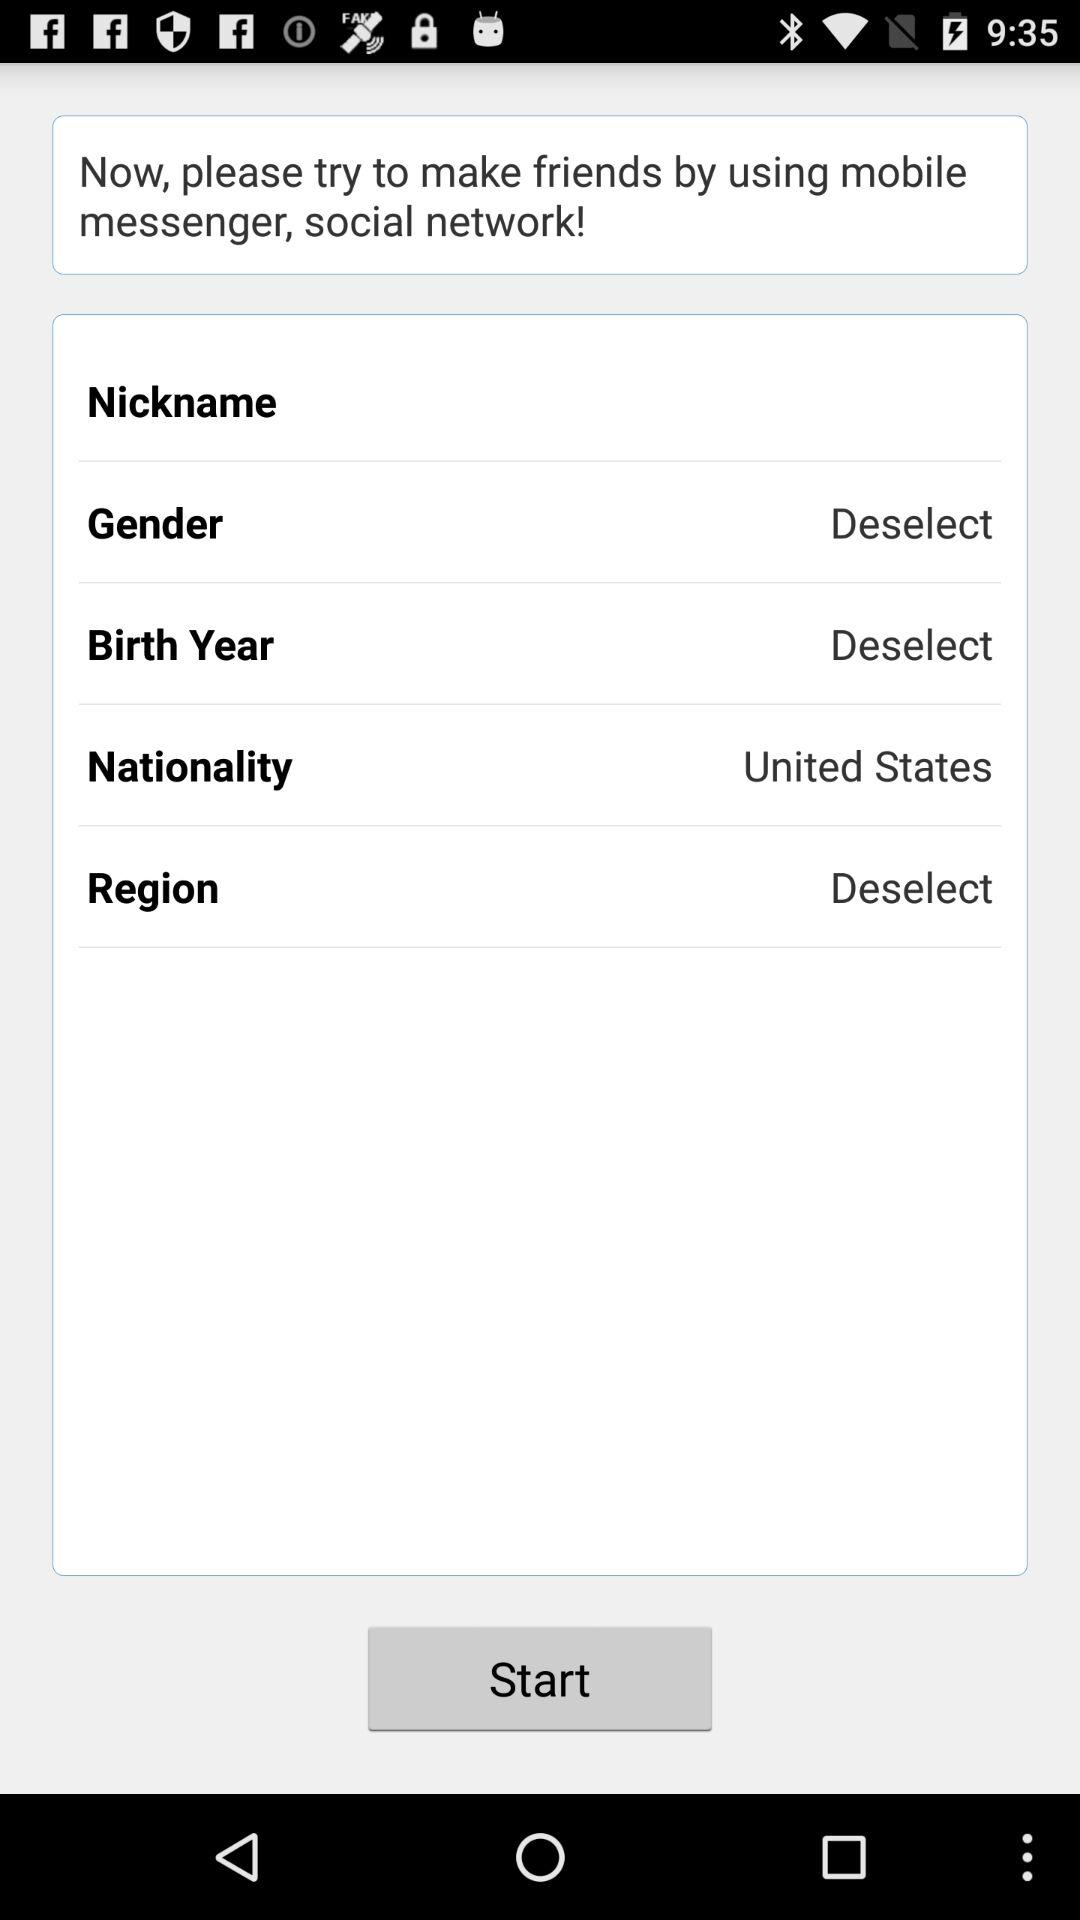Which gender was selected?
When the provided information is insufficient, respond with <no answer>. <no answer> 